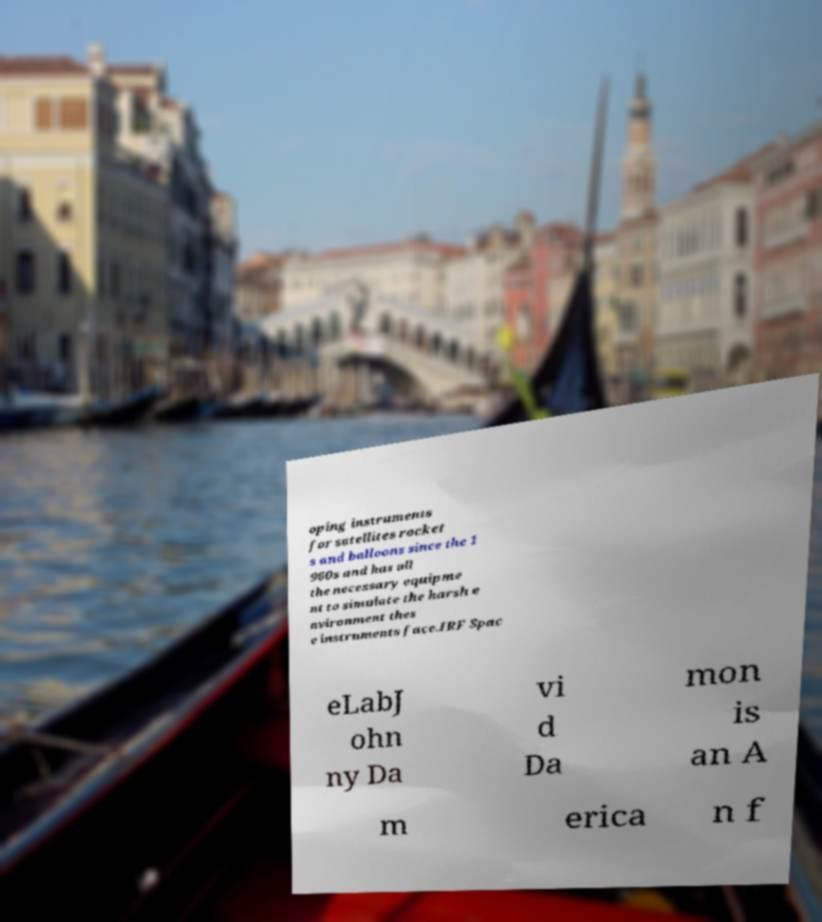Could you extract and type out the text from this image? oping instruments for satellites rocket s and balloons since the 1 960s and has all the necessary equipme nt to simulate the harsh e nvironment thes e instruments face.IRF Spac eLabJ ohn ny Da vi d Da mon is an A m erica n f 